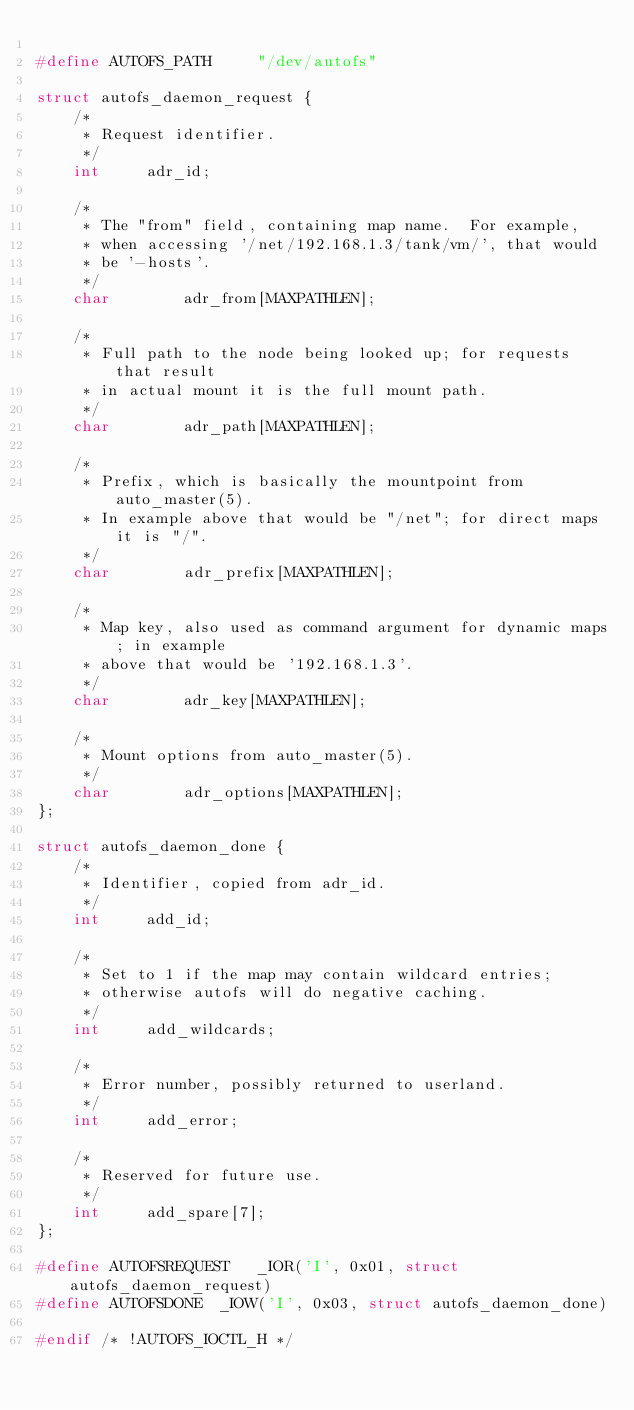Convert code to text. <code><loc_0><loc_0><loc_500><loc_500><_C_>
#define	AUTOFS_PATH		"/dev/autofs"

struct autofs_daemon_request {
	/*
	 * Request identifier.
	 */
	int		adr_id;

	/*
	 * The "from" field, containing map name.  For example,
	 * when accessing '/net/192.168.1.3/tank/vm/', that would
	 * be '-hosts'.
	 */
	char		adr_from[MAXPATHLEN];

	/*
	 * Full path to the node being looked up; for requests that result
	 * in actual mount it is the full mount path.
	 */
	char		adr_path[MAXPATHLEN];

	/*
	 * Prefix, which is basically the mountpoint from auto_master(5).
	 * In example above that would be "/net"; for direct maps it is "/".
	 */
	char		adr_prefix[MAXPATHLEN];

	/*
	 * Map key, also used as command argument for dynamic maps; in example
	 * above that would be '192.168.1.3'.
	 */
	char		adr_key[MAXPATHLEN];

	/*
	 * Mount options from auto_master(5).
	 */
	char		adr_options[MAXPATHLEN];
};

struct autofs_daemon_done {
	/*
	 * Identifier, copied from adr_id.
	 */
	int		add_id;

	/*
	 * Set to 1 if the map may contain wildcard entries;
	 * otherwise autofs will do negative caching.
	 */
	int		add_wildcards;

	/*
	 * Error number, possibly returned to userland.
	 */
	int		add_error;

	/*
	 * Reserved for future use.
	 */
	int		add_spare[7];
};

#define	AUTOFSREQUEST	_IOR('I', 0x01, struct autofs_daemon_request)
#define	AUTOFSDONE	_IOW('I', 0x03, struct autofs_daemon_done)

#endif /* !AUTOFS_IOCTL_H */
</code> 